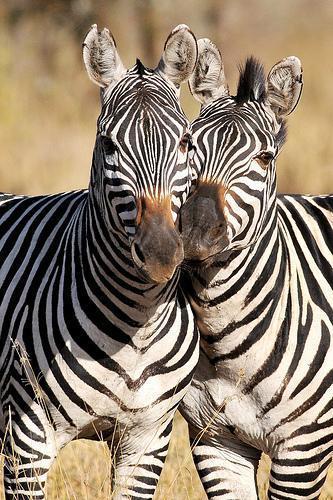How many animals?
Give a very brief answer. 2. 